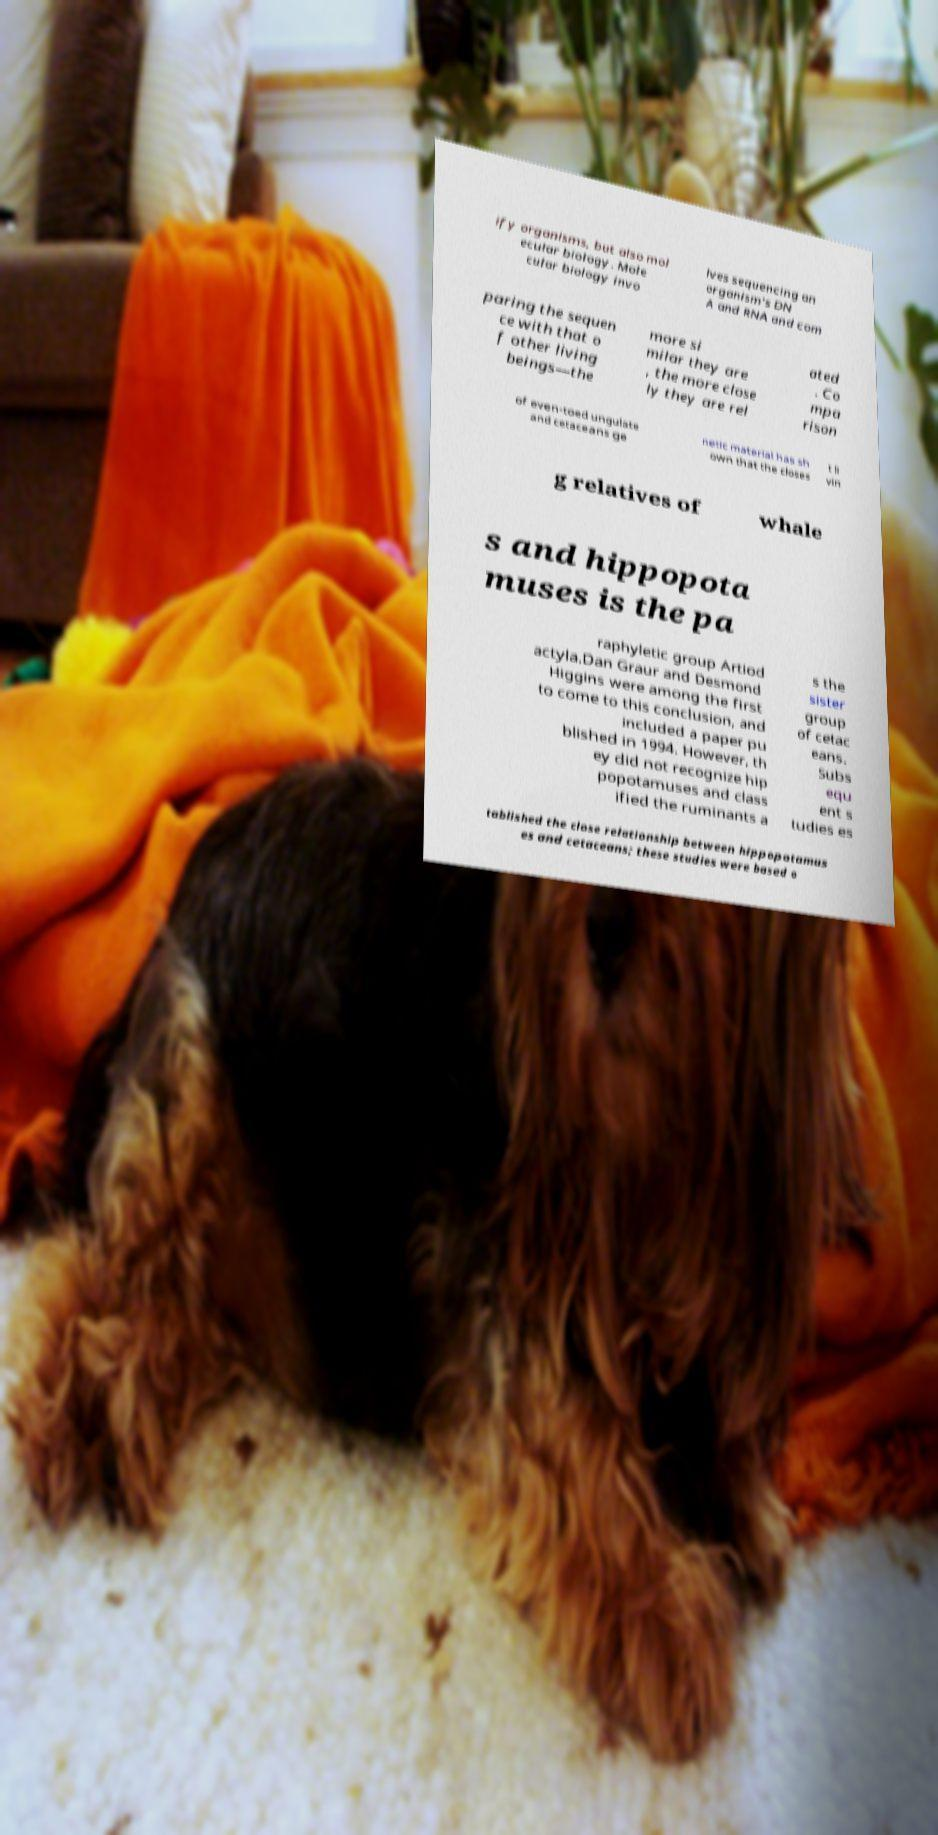Could you assist in decoding the text presented in this image and type it out clearly? ify organisms, but also mol ecular biology. Mole cular biology invo lves sequencing an organism's DN A and RNA and com paring the sequen ce with that o f other living beings—the more si milar they are , the more close ly they are rel ated . Co mpa rison of even-toed ungulate and cetaceans ge netic material has sh own that the closes t li vin g relatives of whale s and hippopota muses is the pa raphyletic group Artiod actyla.Dan Graur and Desmond Higgins were among the first to come to this conclusion, and included a paper pu blished in 1994. However, th ey did not recognize hip popotamuses and class ified the ruminants a s the sister group of cetac eans. Subs equ ent s tudies es tablished the close relationship between hippopotamus es and cetaceans; these studies were based o 